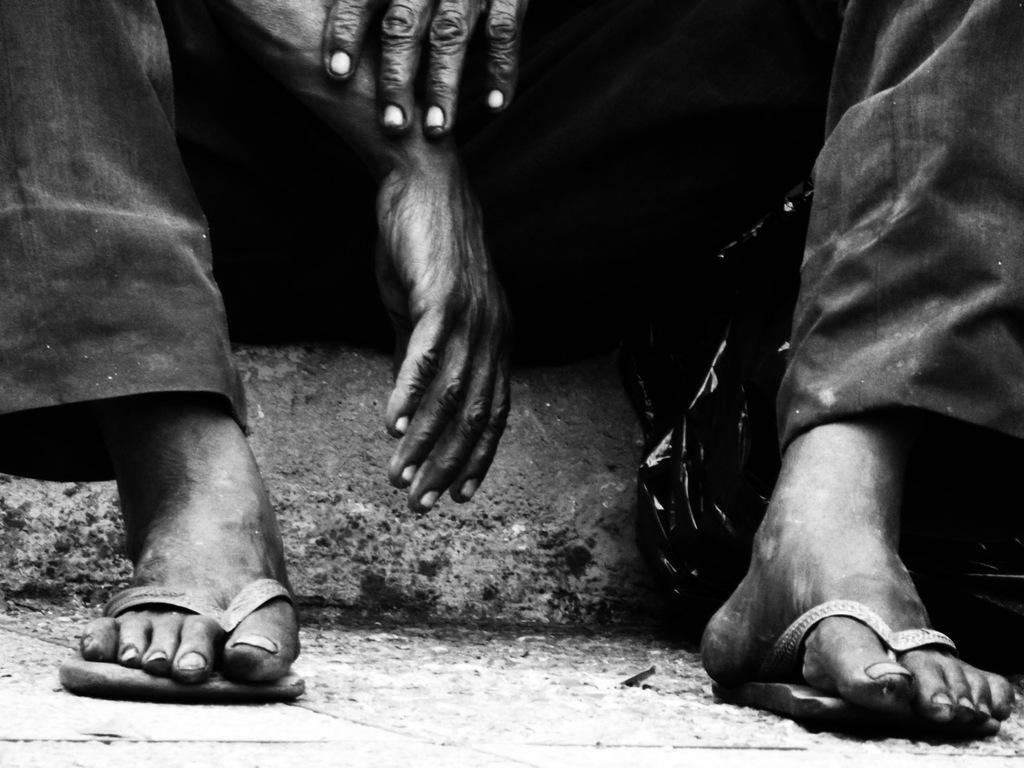What is the color scheme of the image? The image is black and white. What can be seen in the image? There is a person sitting in the image. What parts of the person's body are visible? The person's legs and hands are visible. What is at the bottom of the image? There is a road at the bottom of the image. What type of powder is being used by the group in the image? There is no group or powder present in the image; it features a person sitting in a black and white setting. 